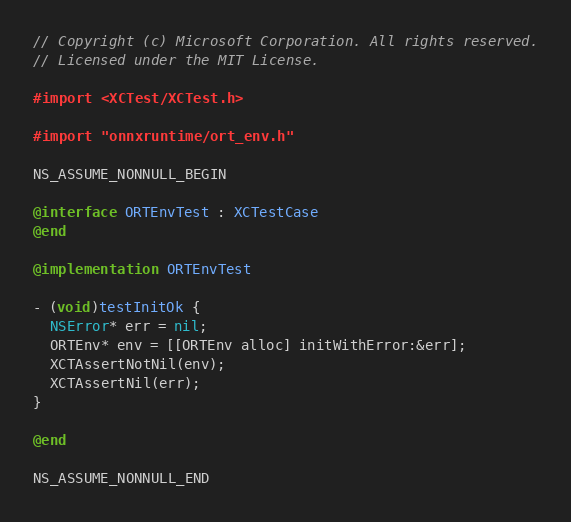<code> <loc_0><loc_0><loc_500><loc_500><_ObjectiveC_>// Copyright (c) Microsoft Corporation. All rights reserved.
// Licensed under the MIT License.

#import <XCTest/XCTest.h>

#import "onnxruntime/ort_env.h"

NS_ASSUME_NONNULL_BEGIN

@interface ORTEnvTest : XCTestCase
@end

@implementation ORTEnvTest

- (void)testInitOk {
  NSError* err = nil;
  ORTEnv* env = [[ORTEnv alloc] initWithError:&err];
  XCTAssertNotNil(env);
  XCTAssertNil(err);
}

@end

NS_ASSUME_NONNULL_END
</code> 